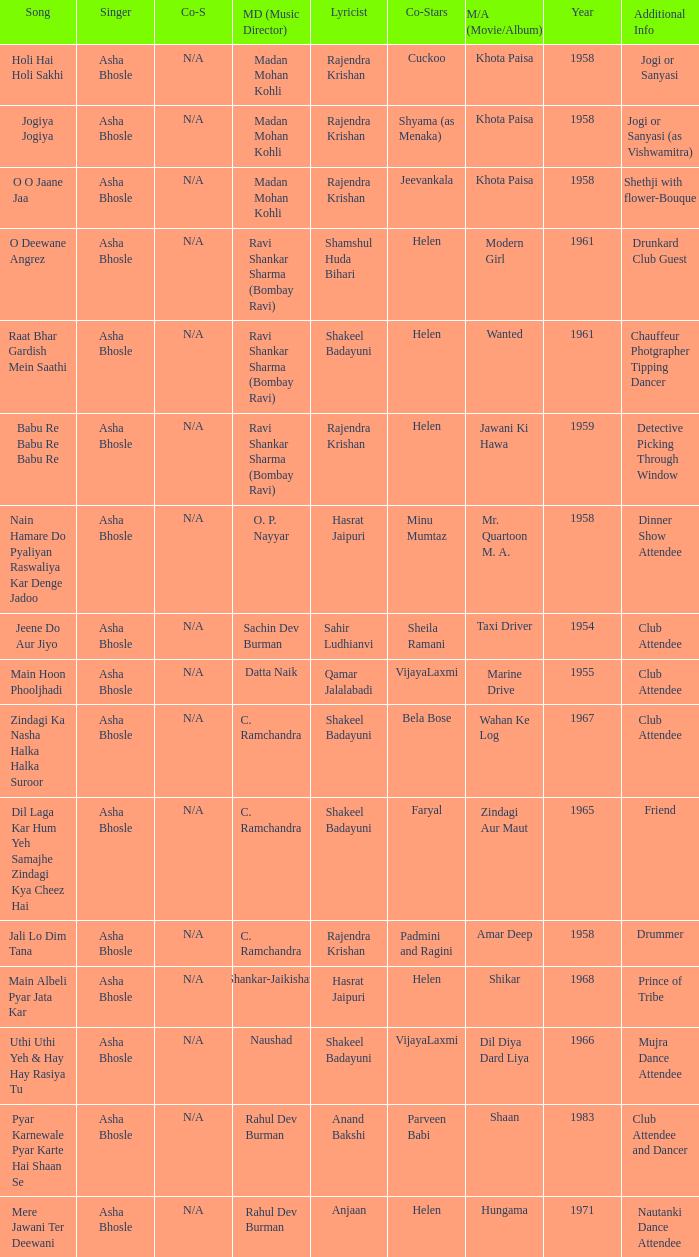Who wrote the lyrics when Jeevankala co-starred? Rajendra Krishan. 